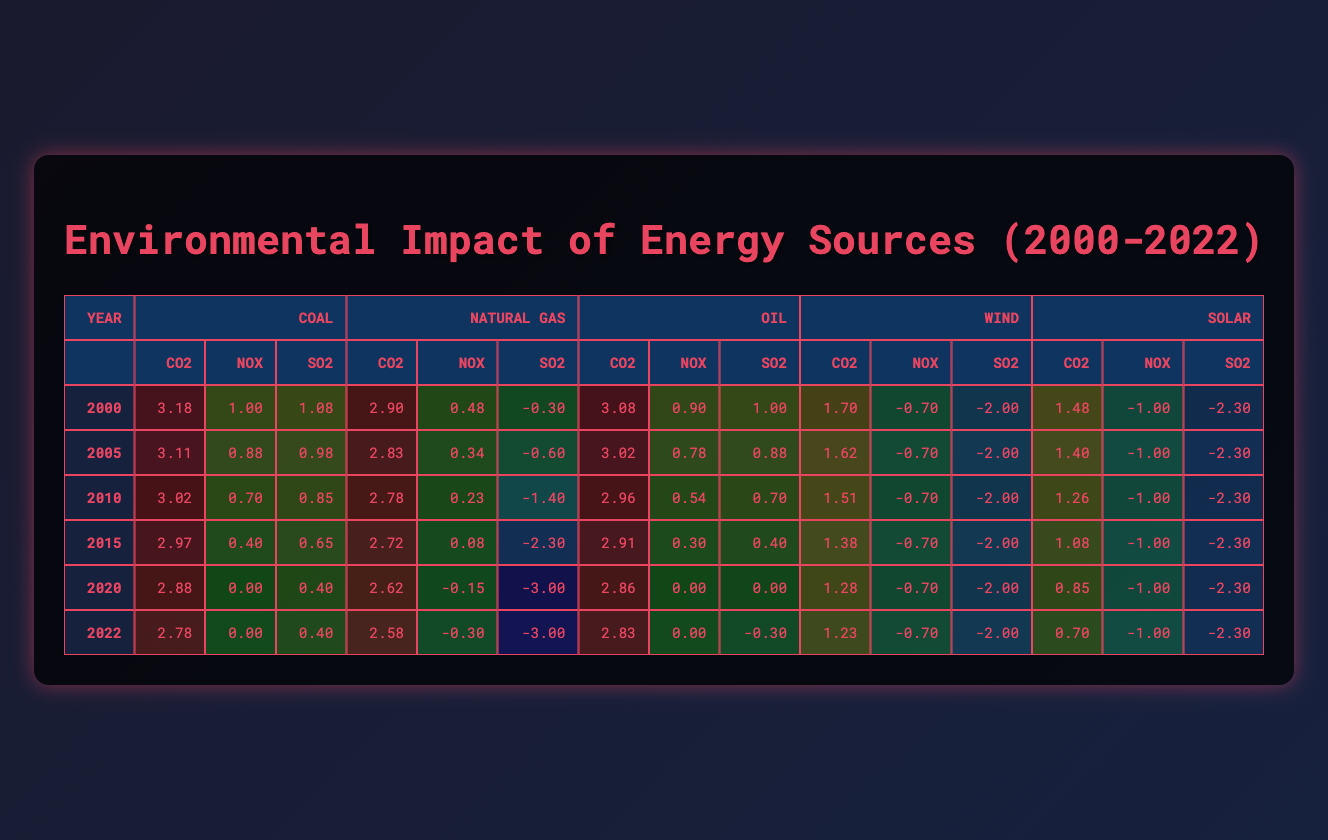What were the CO2 emissions from Coal in 2005? From the table, the CO2 emissions for Coal in the year 2005 are listed directly under the CO2 column for that energy source, which shows a value of 3.11.
Answer: 3.11 What is the trend of SO2 emissions from Natural Gas from 2000 to 2022? Looking at the SO2 emissions for Natural Gas over the years, it can be observed that it starts at -0.30 in 2000 and consistently decreases to 0 in 2022. This indicates a downward trend in SO2 emissions over this time period.
Answer: Decreasing trend What was the average NOx emissions from Wind between 2000 and 2022? The NOx emissions from Wind from 2000 to 2022 all show the same value of 0.2 tons every year. To find the average, we can sum up all the NOx values (0.2 * 23 = 4.6) and divide by the number of years (23). Therefore, the average is 4.6/23 which simplifies to 0.2.
Answer: 0.2 Did the CO2 emissions from Oil ever drop below 800 tons during the given years? By checking the CO2 emissions for Oil from 2000 to 2022, we see that the values range from 3.08 down to 2.83 but never reach below 800 tons. Thus, the answer is no.
Answer: No What is the difference between the CO2 emissions from Coal in 2000 and Solar in 2022? The CO2 emissions from Coal in 2000 are 3.18, and from Solar in 2022 are 0.70. To find the difference, we subtract the latter from the former: 3.18 - 0.70 = 2.48.
Answer: 2.48 